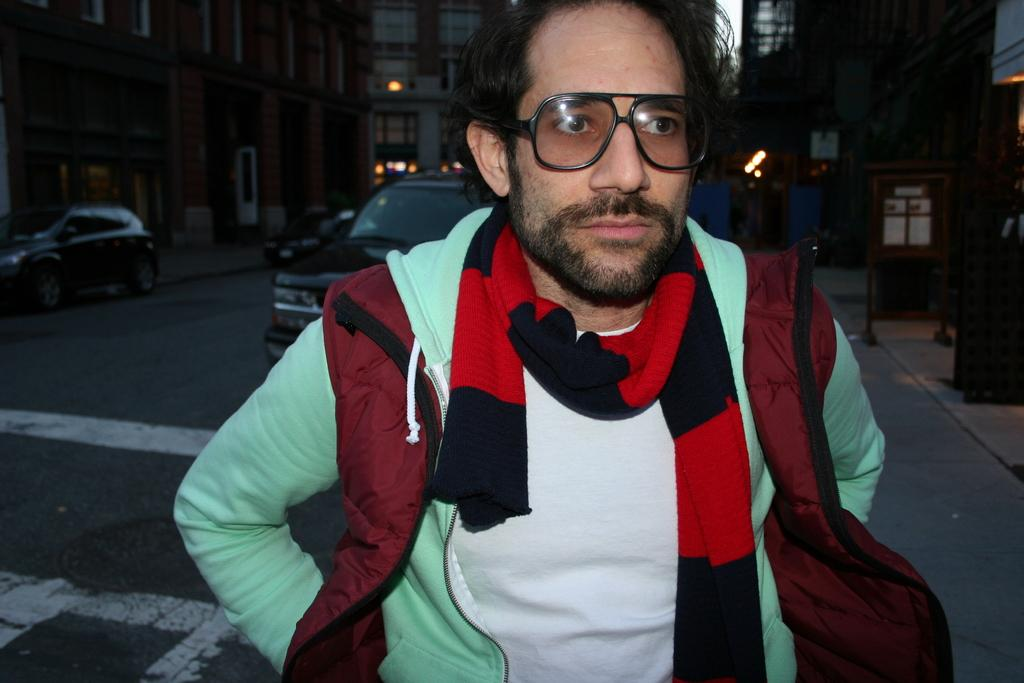What is the main subject of the image? There is a person standing in the image. Can you describe the person's attire? The person is wearing a white and green color dress. What can be seen in the background of the image? There are vehicles, lights, and buildings in the background of the image. How many clocks are hanging on the wall in the image? There are no clocks visible in the image. What level of the building is the person standing on in the image? The image does not provide information about the level of the building. 